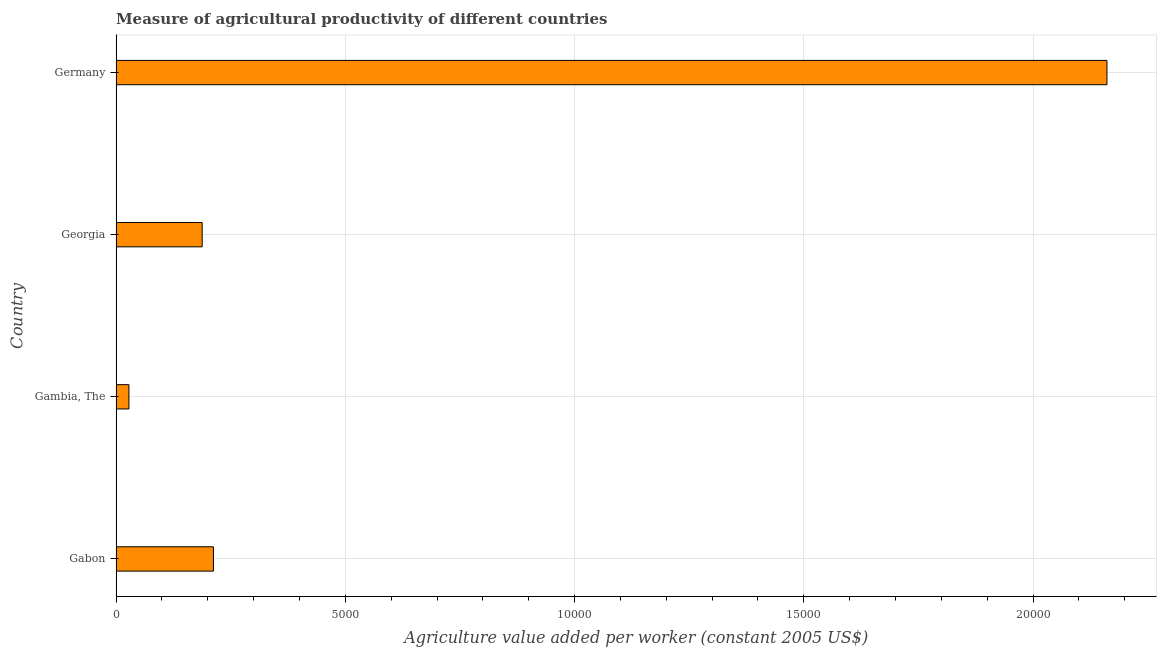What is the title of the graph?
Your answer should be very brief. Measure of agricultural productivity of different countries. What is the label or title of the X-axis?
Provide a succinct answer. Agriculture value added per worker (constant 2005 US$). What is the label or title of the Y-axis?
Make the answer very short. Country. What is the agriculture value added per worker in Gabon?
Offer a terse response. 2122.09. Across all countries, what is the maximum agriculture value added per worker?
Make the answer very short. 2.16e+04. Across all countries, what is the minimum agriculture value added per worker?
Your answer should be compact. 279.05. In which country was the agriculture value added per worker maximum?
Offer a very short reply. Germany. In which country was the agriculture value added per worker minimum?
Provide a succinct answer. Gambia, The. What is the sum of the agriculture value added per worker?
Ensure brevity in your answer.  2.59e+04. What is the difference between the agriculture value added per worker in Gabon and Germany?
Provide a short and direct response. -1.95e+04. What is the average agriculture value added per worker per country?
Your answer should be compact. 6472.47. What is the median agriculture value added per worker?
Offer a terse response. 1999.46. In how many countries, is the agriculture value added per worker greater than 12000 US$?
Ensure brevity in your answer.  1. What is the ratio of the agriculture value added per worker in Gabon to that in Georgia?
Your response must be concise. 1.13. Is the difference between the agriculture value added per worker in Gambia, The and Germany greater than the difference between any two countries?
Offer a terse response. Yes. What is the difference between the highest and the second highest agriculture value added per worker?
Offer a very short reply. 1.95e+04. Is the sum of the agriculture value added per worker in Gabon and Georgia greater than the maximum agriculture value added per worker across all countries?
Offer a terse response. No. What is the difference between the highest and the lowest agriculture value added per worker?
Keep it short and to the point. 2.13e+04. Are all the bars in the graph horizontal?
Offer a terse response. Yes. How many countries are there in the graph?
Offer a very short reply. 4. What is the difference between two consecutive major ticks on the X-axis?
Provide a short and direct response. 5000. Are the values on the major ticks of X-axis written in scientific E-notation?
Provide a succinct answer. No. What is the Agriculture value added per worker (constant 2005 US$) in Gabon?
Provide a short and direct response. 2122.09. What is the Agriculture value added per worker (constant 2005 US$) in Gambia, The?
Make the answer very short. 279.05. What is the Agriculture value added per worker (constant 2005 US$) in Georgia?
Give a very brief answer. 1876.84. What is the Agriculture value added per worker (constant 2005 US$) in Germany?
Keep it short and to the point. 2.16e+04. What is the difference between the Agriculture value added per worker (constant 2005 US$) in Gabon and Gambia, The?
Your answer should be very brief. 1843.04. What is the difference between the Agriculture value added per worker (constant 2005 US$) in Gabon and Georgia?
Your response must be concise. 245.25. What is the difference between the Agriculture value added per worker (constant 2005 US$) in Gabon and Germany?
Your response must be concise. -1.95e+04. What is the difference between the Agriculture value added per worker (constant 2005 US$) in Gambia, The and Georgia?
Make the answer very short. -1597.78. What is the difference between the Agriculture value added per worker (constant 2005 US$) in Gambia, The and Germany?
Make the answer very short. -2.13e+04. What is the difference between the Agriculture value added per worker (constant 2005 US$) in Georgia and Germany?
Provide a short and direct response. -1.97e+04. What is the ratio of the Agriculture value added per worker (constant 2005 US$) in Gabon to that in Gambia, The?
Make the answer very short. 7.61. What is the ratio of the Agriculture value added per worker (constant 2005 US$) in Gabon to that in Georgia?
Offer a terse response. 1.13. What is the ratio of the Agriculture value added per worker (constant 2005 US$) in Gabon to that in Germany?
Give a very brief answer. 0.1. What is the ratio of the Agriculture value added per worker (constant 2005 US$) in Gambia, The to that in Georgia?
Give a very brief answer. 0.15. What is the ratio of the Agriculture value added per worker (constant 2005 US$) in Gambia, The to that in Germany?
Provide a short and direct response. 0.01. What is the ratio of the Agriculture value added per worker (constant 2005 US$) in Georgia to that in Germany?
Provide a succinct answer. 0.09. 